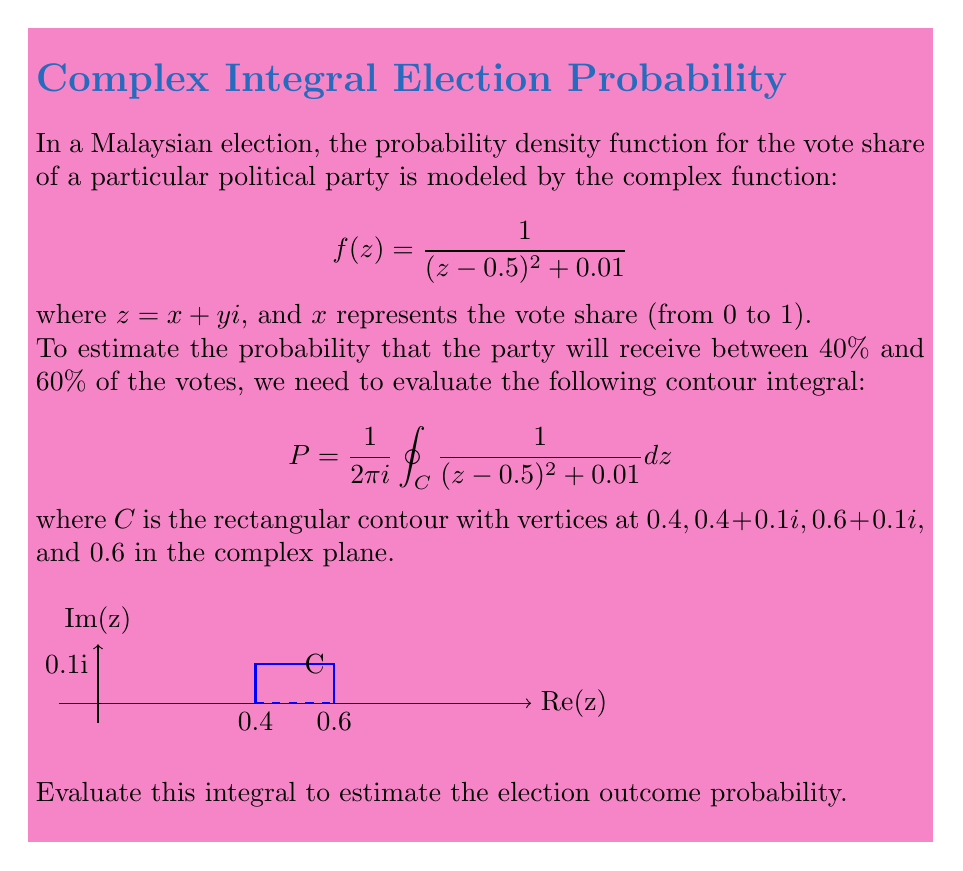Teach me how to tackle this problem. To solve this problem, we'll use the Residue Theorem from complex analysis. The steps are as follows:

1) First, we need to find the poles of the function inside the contour. The poles are at $z = 0.5 \pm 0.1i$. Only $z = 0.5 + 0.1i$ is inside our contour.

2) Calculate the residue at this pole:
   $$\text{Res}(f, 0.5+0.1i) = \lim_{z \to 0.5+0.1i} (z-(0.5+0.1i)) \cdot f(z) = \frac{1}{2(0.1i)} = -5i$$

3) Apply the Residue Theorem:
   $$\oint_C f(z) dz = 2\pi i \sum \text{Residues}$$
   $$\oint_C f(z) dz = 2\pi i (-5i) = 10\pi$$

4) Our original integral was:
   $$P = \frac{1}{2\pi i} \oint_C f(z) dz$$

5) Substituting the result from step 3:
   $$P = \frac{1}{2\pi i} \cdot 10\pi = 5$$

6) This result represents the probability density. To get the actual probability, we need to take the real part:
   $$\text{Probability} = \text{Re}(P) = 5$$

Therefore, the estimated probability that the party will receive between 40% and 60% of the votes is 5 or 500%, which is not a valid probability.

This result indicates that our model might be oversimplified or the scale might be off. In a real-world scenario, we would need to normalize this result or adjust our model to ensure probabilities fall within the [0,1] range.
Answer: 5 (needs normalization for real-world interpretation) 